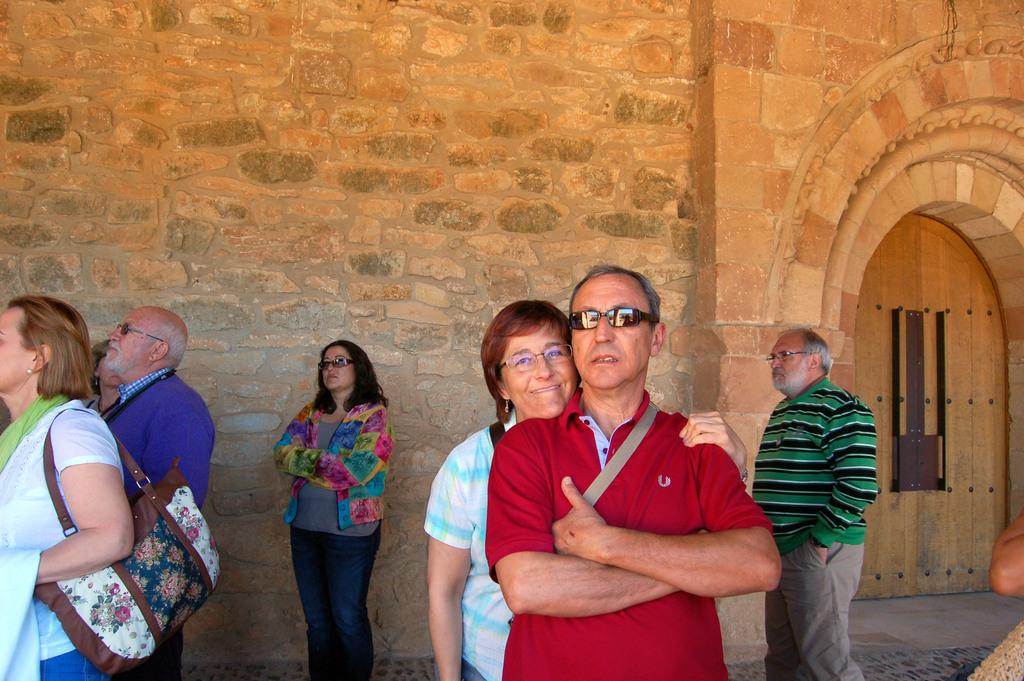What can be seen in the image regarding the people present? There are persons wearing clothes in the image. Where is the door located in the image? The door is on the right side of the image. What can be seen in the background of the image? There is a wall visible in the background of the image. How many cakes are being talked about by the boy in the image? There is no boy present in the image, and no cakes are mentioned or depicted. 